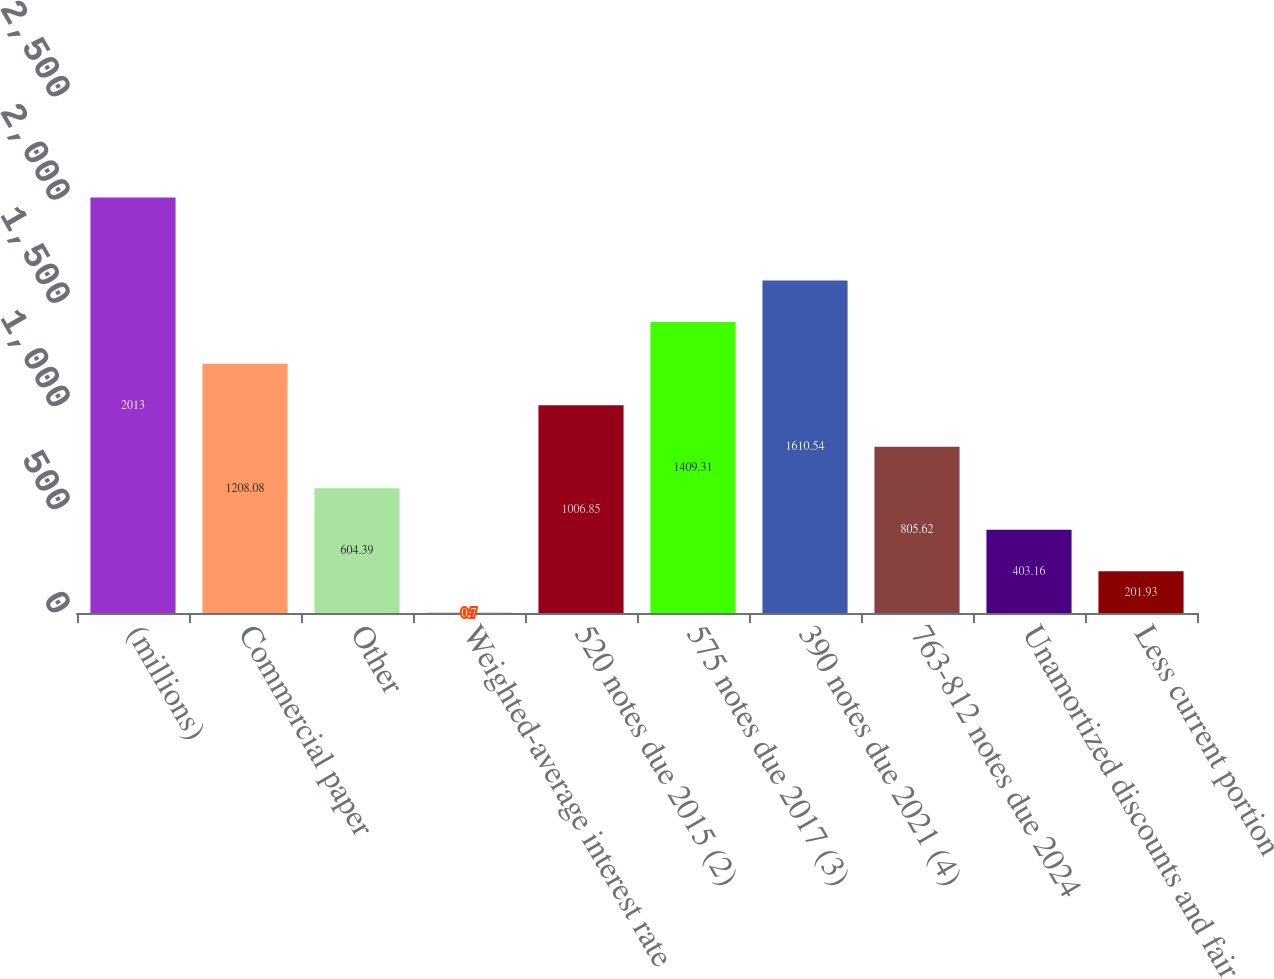Convert chart to OTSL. <chart><loc_0><loc_0><loc_500><loc_500><bar_chart><fcel>(millions)<fcel>Commercial paper<fcel>Other<fcel>Weighted-average interest rate<fcel>520 notes due 2015 (2)<fcel>575 notes due 2017 (3)<fcel>390 notes due 2021 (4)<fcel>763-812 notes due 2024<fcel>Unamortized discounts and fair<fcel>Less current portion<nl><fcel>2013<fcel>1208.08<fcel>604.39<fcel>0.7<fcel>1006.85<fcel>1409.31<fcel>1610.54<fcel>805.62<fcel>403.16<fcel>201.93<nl></chart> 